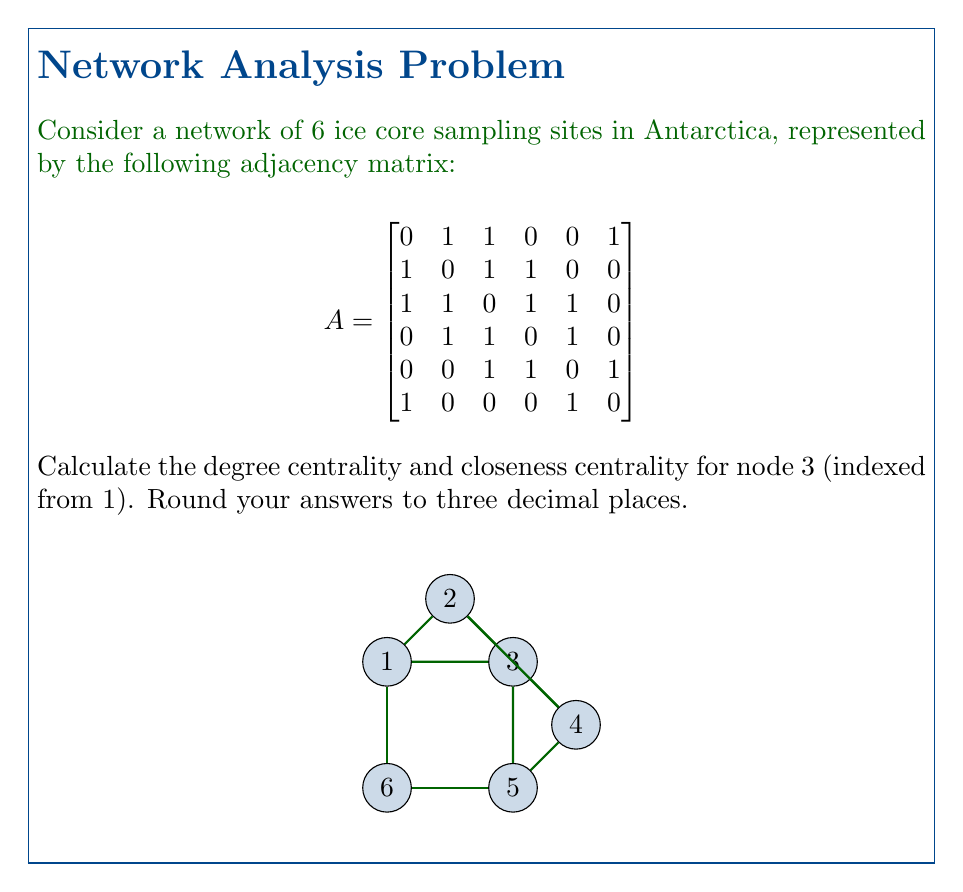Solve this math problem. 1. Degree Centrality:
   - Degree centrality is the number of direct connections a node has, normalized by the maximum possible connections.
   - For node 3, we count the number of 1's in the third row (or column) of the adjacency matrix.
   - Node 3 has 4 connections (to nodes 1, 2, 3, and 4).
   - The maximum possible connections in a network with 6 nodes is 5.
   - Degree centrality = $\frac{4}{5} = 0.8$

2. Closeness Centrality:
   - Closeness centrality measures how close a node is to all other nodes in the network.
   - First, we need to calculate the shortest path lengths from node 3 to all other nodes:
     * To node 1: 1 step
     * To node 2: 1 step
     * To node 3: 0 steps (itself)
     * To node 4: 1 step
     * To node 5: 1 step
     * To node 6: 2 steps (through node 1 or 5)
   - Sum of shortest paths: 1 + 1 + 0 + 1 + 1 + 2 = 6
   - Closeness centrality is calculated as: $\frac{n-1}{\text{sum of shortest paths}}$, where n is the number of nodes.
   - Closeness centrality = $\frac{6-1}{6} = \frac{5}{6} \approx 0.833$

Both values are rounded to three decimal places as requested.
Answer: Degree centrality: 0.800, Closeness centrality: 0.833 